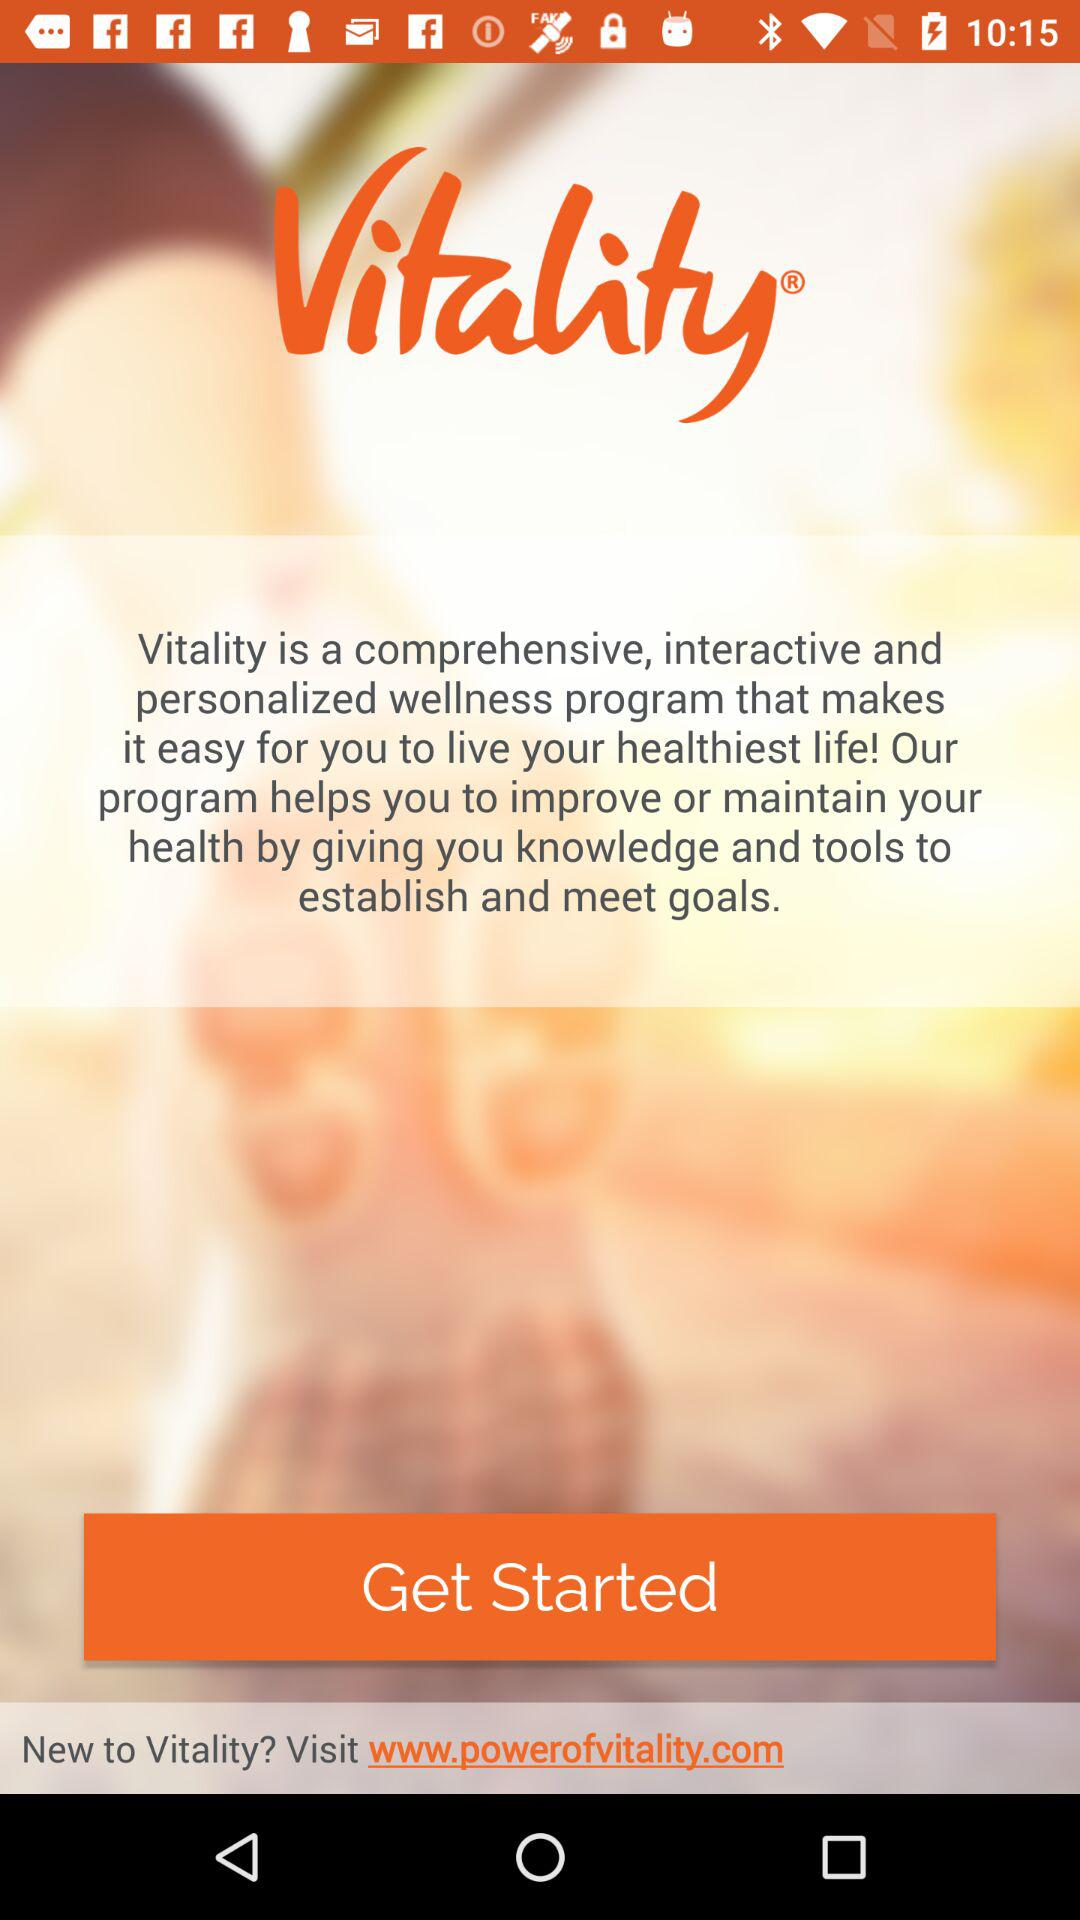What is the application name? The application name is "Vitality". 